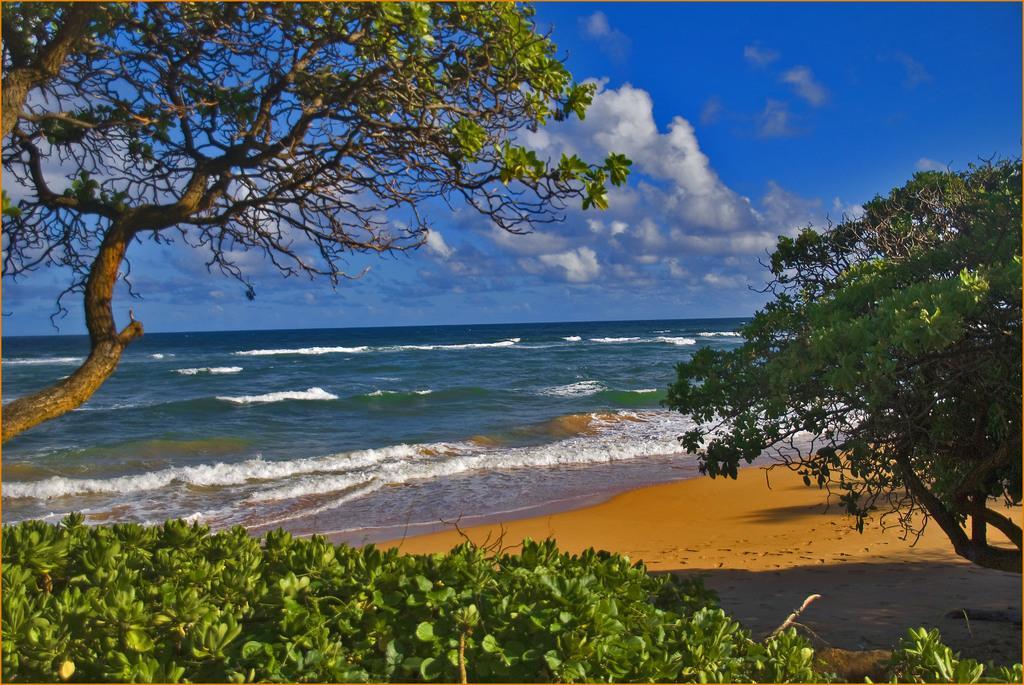Can you describe this image briefly? In this image we can see a large water body. we can also see some trees, plants and the sky which looks cloudy. 